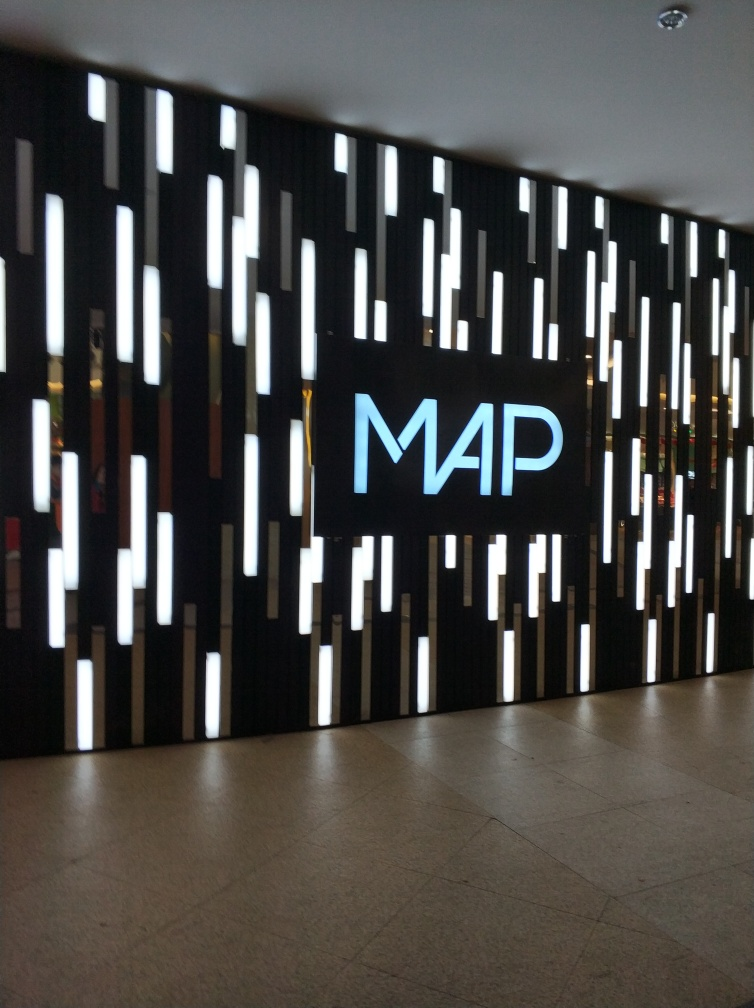What atmosphere or mood does the lighting design on this wall convey? The lighting design on the wall gives off a modern and sophisticated ambiance. The cool white lights interspersed with the dark background create a contrast that might be seen as both futuristic and elegant, suggesting a space that is stylish and contemporary. 